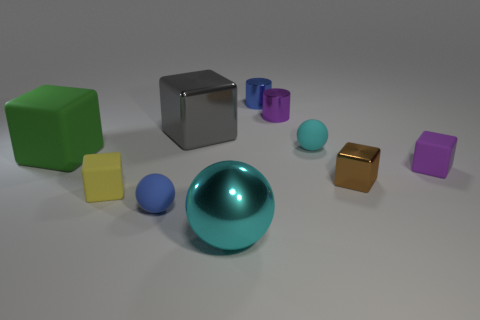Is the number of big metallic cubes to the right of the purple block greater than the number of big brown matte spheres?
Give a very brief answer. No. How many metallic things are both in front of the tiny blue ball and to the right of the blue shiny cylinder?
Give a very brief answer. 0. The matte ball in front of the small rubber block that is to the left of the brown cube is what color?
Your answer should be very brief. Blue. How many metallic balls have the same color as the large metal cube?
Offer a very short reply. 0. Does the small shiny block have the same color as the rubber block that is to the right of the yellow matte cube?
Ensure brevity in your answer.  No. Is the number of green blocks less than the number of big red spheres?
Provide a short and direct response. No. Is the number of small objects that are to the left of the large matte cube greater than the number of large matte cubes that are right of the large cyan thing?
Your answer should be compact. No. Do the tiny cyan sphere and the blue ball have the same material?
Provide a succinct answer. Yes. There is a big metallic object that is left of the large cyan ball; how many big shiny blocks are in front of it?
Give a very brief answer. 0. There is a large thing that is right of the big gray thing; is its color the same as the big rubber cube?
Make the answer very short. No. 